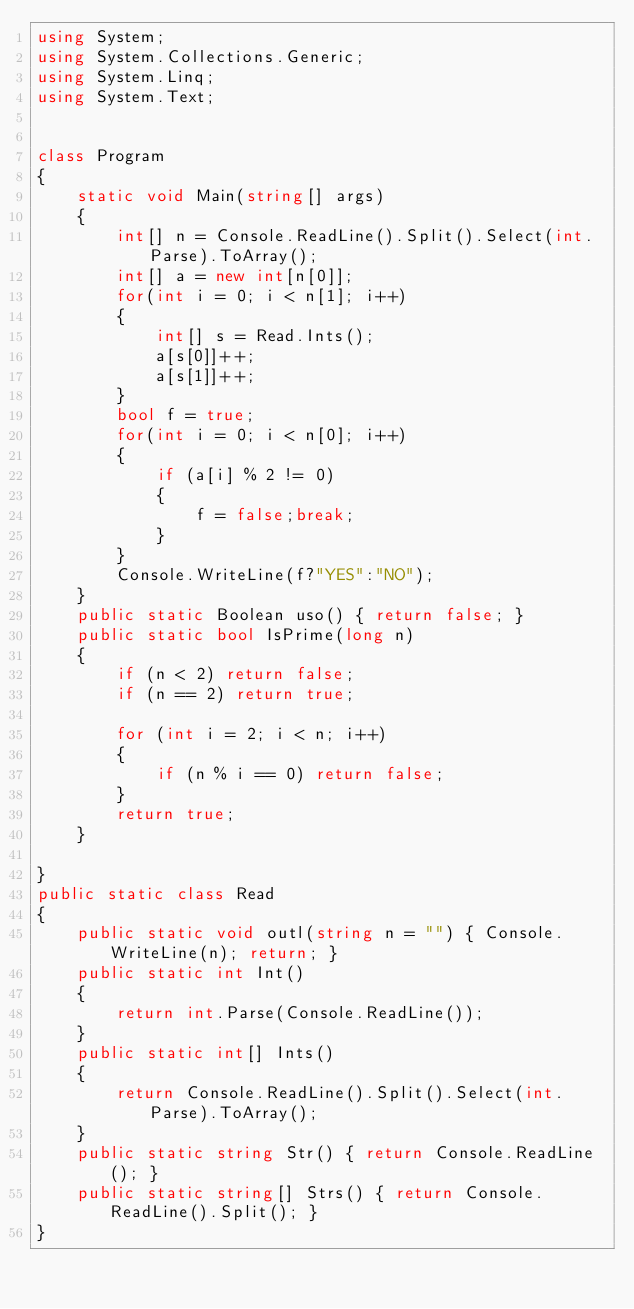Convert code to text. <code><loc_0><loc_0><loc_500><loc_500><_C#_>using System;
using System.Collections.Generic;
using System.Linq;
using System.Text;


class Program
{
    static void Main(string[] args)
    {
        int[] n = Console.ReadLine().Split().Select(int.Parse).ToArray();
        int[] a = new int[n[0]];
        for(int i = 0; i < n[1]; i++)
        {
            int[] s = Read.Ints();
            a[s[0]]++;
            a[s[1]]++;
        }
        bool f = true;
        for(int i = 0; i < n[0]; i++)
        {
            if (a[i] % 2 != 0)
            {
                f = false;break;
            }
        }
        Console.WriteLine(f?"YES":"NO");
    }
    public static Boolean uso() { return false; }
    public static bool IsPrime(long n)
    {
        if (n < 2) return false;
        if (n == 2) return true;

        for (int i = 2; i < n; i++)
        {
            if (n % i == 0) return false;
        }
        return true;
    }

}
public static class Read
{
    public static void outl(string n = "") { Console.WriteLine(n); return; }
    public static int Int()
    {
        return int.Parse(Console.ReadLine());
    }
    public static int[] Ints()
    {
        return Console.ReadLine().Split().Select(int.Parse).ToArray();
    }
    public static string Str() { return Console.ReadLine(); }
    public static string[] Strs() { return Console.ReadLine().Split(); }
}</code> 